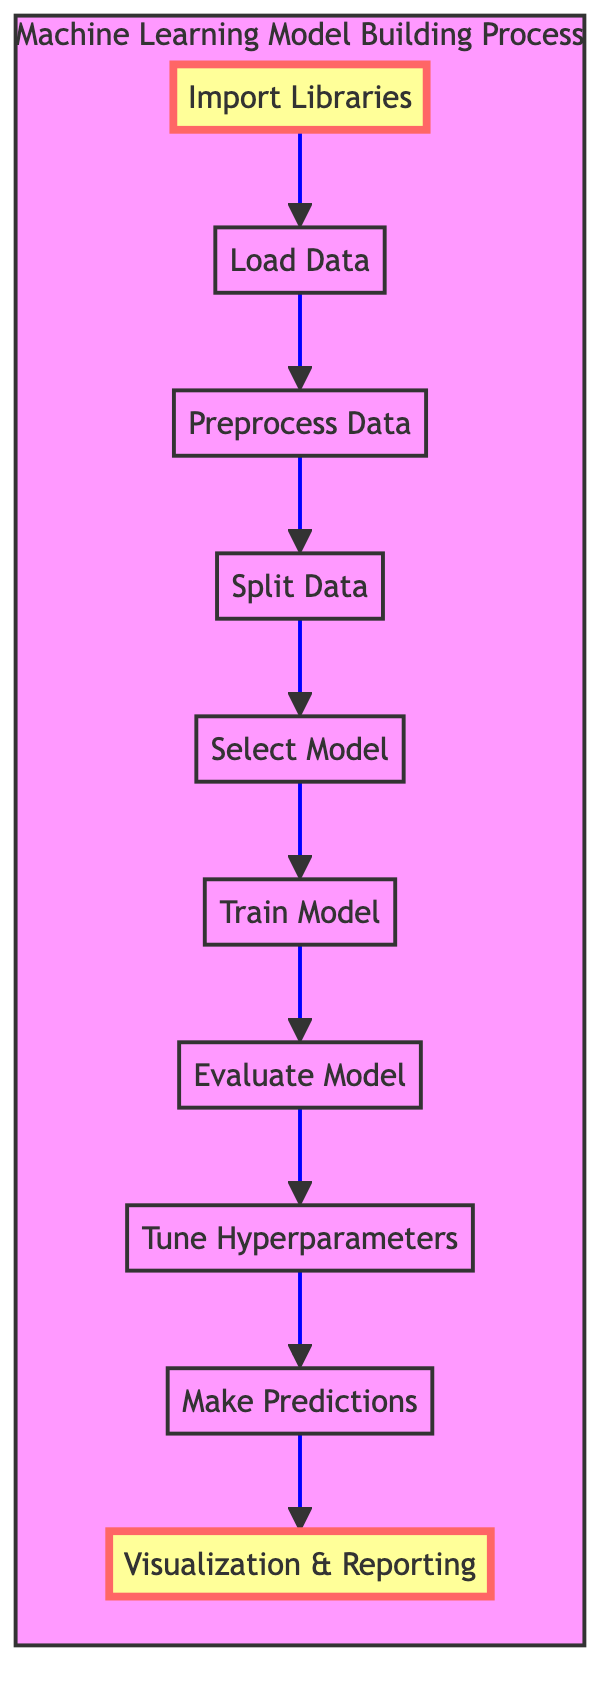What is the first step in the process? The first step in the process is "Import Libraries," which is located at the bottom of the flowchart. This step is crucial as it sets up the environment by bringing in necessary libraries needed for machine learning tasks.
Answer: Import Libraries How many nodes are there in the diagram? The diagram contains a total of 10 nodes, each representing a key step in the machine learning model building process, from importing libraries to visualization and reporting.
Answer: 10 What is the last step in the process? The last step in the flowchart is "Visualization & Reporting," located at the top of the diagram. This step allows you to analyze the model's performance visually and communicate the results effectively.
Answer: Visualization & Reporting Which step comes after "Evaluate Model"? Following "Evaluate Model," which assesses the model's performance, the next step in the process is "Tune Hyperparameters." This step involves optimizing the model's parameters to improve its performance.
Answer: Tune Hyperparameters What is the relationship between "Train Model" and "Select Model"? "Train Model" comes after "Select Model" in the flowchart. This indicates that you first select an appropriate machine learning algorithm before fitting or training the model on the training data.
Answer: Select Model → Train Model Which step involves optimizing model parameters? The step that involves optimizing model parameters is "Tune Hyperparameters," which uses techniques such as GridSearchCV or RandomizedSearchCV to achieve the best performance from the model.
Answer: Tune Hyperparameters What step is highlighted in the diagram? The steps that are highlighted in the diagram are "Import Libraries" and "Visualization & Reporting." Highlighting these steps emphasizes their importance in the overall process of building and training a machine learning model.
Answer: Import Libraries, Visualization & Reporting How does the flowchart visualize the process? The flowchart visualizes the process by showing a linear progression from the bottom node (Import Libraries) to the top node (Visualization & Reporting), indicating a sequential order of steps necessary for building and training a machine learning model.
Answer: Sequentially from bottom to top 